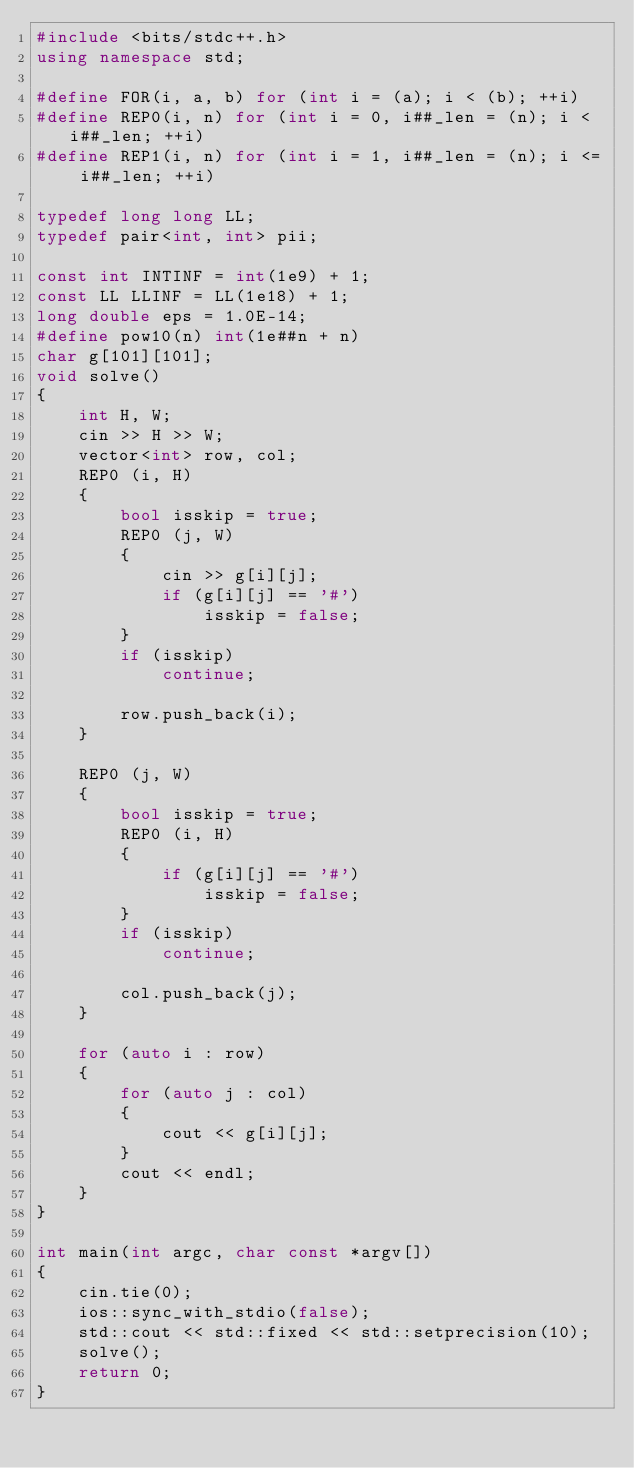<code> <loc_0><loc_0><loc_500><loc_500><_C++_>#include <bits/stdc++.h>
using namespace std;

#define FOR(i, a, b) for (int i = (a); i < (b); ++i)
#define REP0(i, n) for (int i = 0, i##_len = (n); i < i##_len; ++i)
#define REP1(i, n) for (int i = 1, i##_len = (n); i <= i##_len; ++i)

typedef long long LL;
typedef pair<int, int> pii;

const int INTINF = int(1e9) + 1;
const LL LLINF = LL(1e18) + 1;
long double eps = 1.0E-14;
#define pow10(n) int(1e##n + n)
char g[101][101];
void solve()
{
    int H, W;
    cin >> H >> W;
    vector<int> row, col;
    REP0 (i, H)
    {
        bool isskip = true;
        REP0 (j, W)
        {
            cin >> g[i][j];
            if (g[i][j] == '#')
                isskip = false;
        }
        if (isskip)
            continue;

        row.push_back(i);
    }

    REP0 (j, W)
    {
        bool isskip = true;
        REP0 (i, H)
        {
            if (g[i][j] == '#')
                isskip = false;
        }
        if (isskip)
            continue;

        col.push_back(j);
    }

    for (auto i : row)
    {
        for (auto j : col)
        {
            cout << g[i][j];
        }
        cout << endl;
    }
}

int main(int argc, char const *argv[])
{
    cin.tie(0);
    ios::sync_with_stdio(false);
    std::cout << std::fixed << std::setprecision(10);
    solve();
    return 0;
}
</code> 